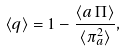<formula> <loc_0><loc_0><loc_500><loc_500>\langle q \rangle = 1 - \frac { \langle a \, \Pi \rangle } { \langle \pi _ { a } ^ { 2 } \rangle } ,</formula> 